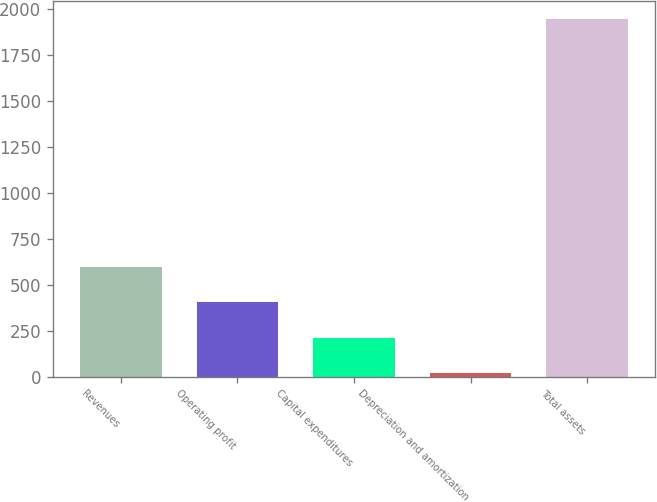<chart> <loc_0><loc_0><loc_500><loc_500><bar_chart><fcel>Revenues<fcel>Operating profit<fcel>Capital expenditures<fcel>Depreciation and amortization<fcel>Total assets<nl><fcel>596.7<fcel>403.8<fcel>210.9<fcel>18<fcel>1947<nl></chart> 